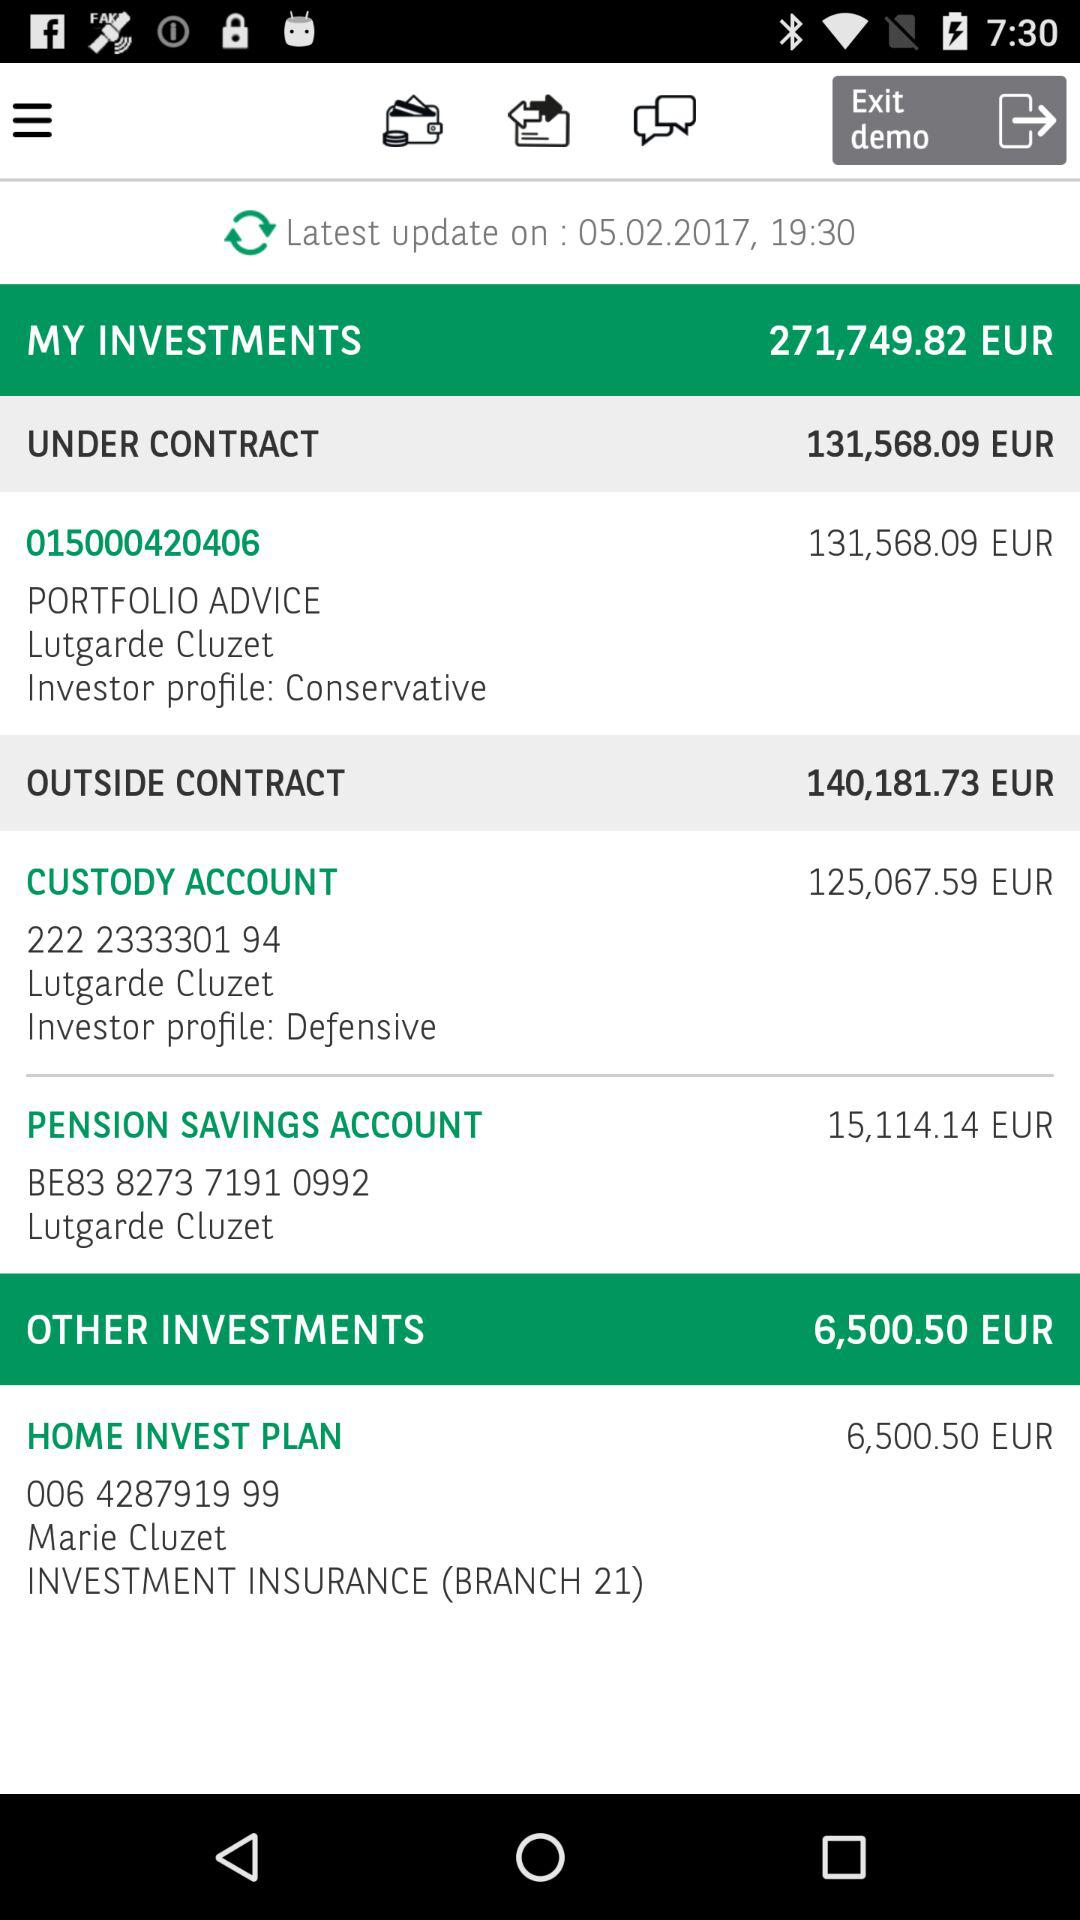How much EUR is the outside contract? The outside contract is 140,181.73 EUR. 